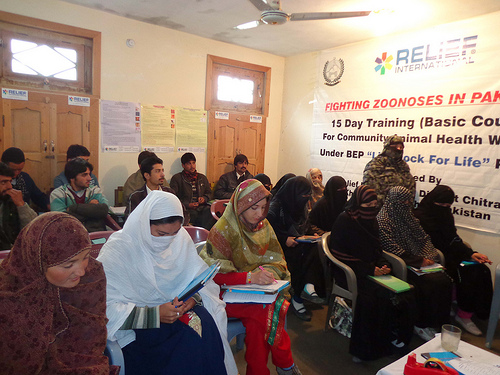<image>
Is the women to the left of the women? Yes. From this viewpoint, the women is positioned to the left side relative to the women. Is there a ceiling fan above the woman? Yes. The ceiling fan is positioned above the woman in the vertical space, higher up in the scene. 